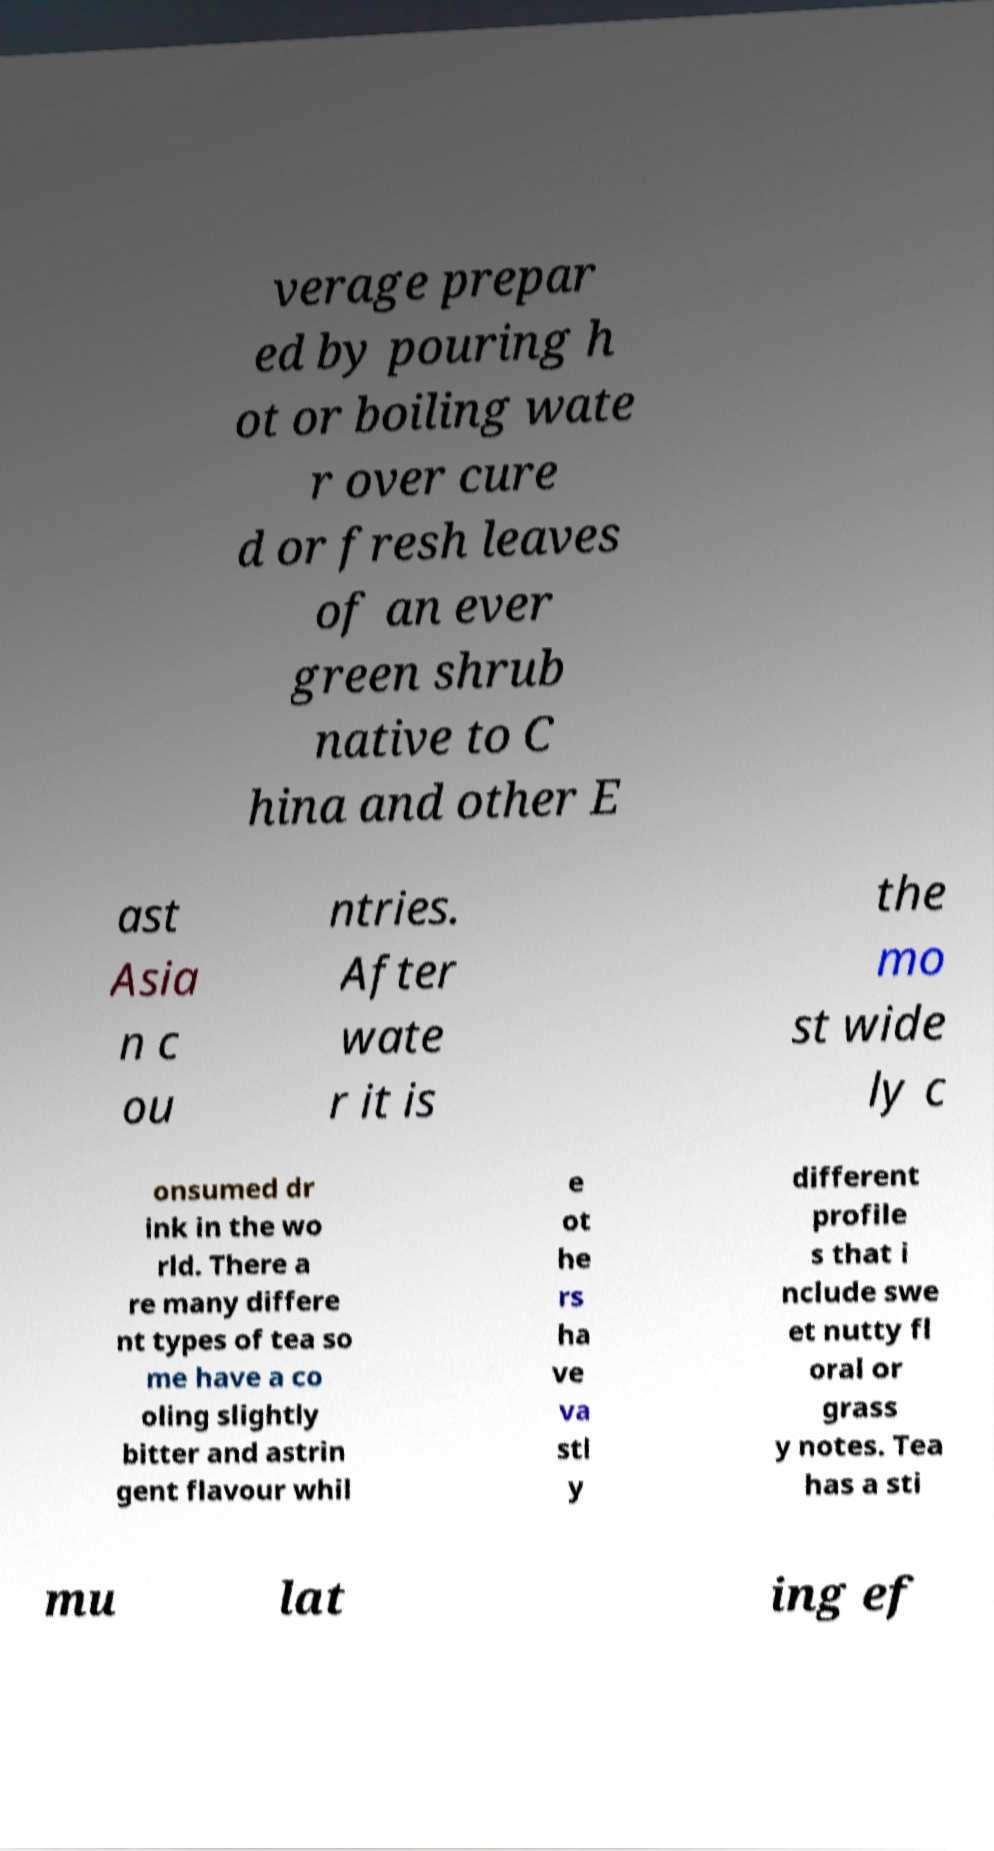There's text embedded in this image that I need extracted. Can you transcribe it verbatim? verage prepar ed by pouring h ot or boiling wate r over cure d or fresh leaves of an ever green shrub native to C hina and other E ast Asia n c ou ntries. After wate r it is the mo st wide ly c onsumed dr ink in the wo rld. There a re many differe nt types of tea so me have a co oling slightly bitter and astrin gent flavour whil e ot he rs ha ve va stl y different profile s that i nclude swe et nutty fl oral or grass y notes. Tea has a sti mu lat ing ef 